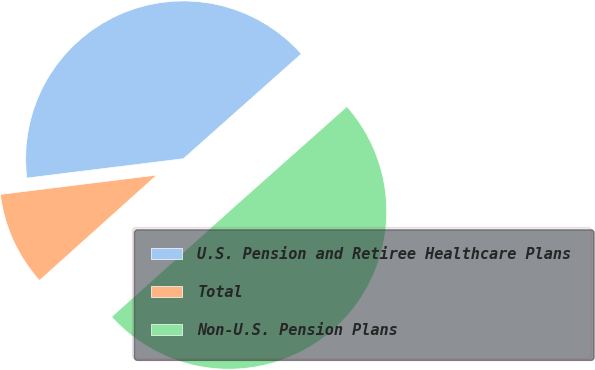Convert chart to OTSL. <chart><loc_0><loc_0><loc_500><loc_500><pie_chart><fcel>U.S. Pension and Retiree Healthcare Plans<fcel>Total<fcel>Non-U.S. Pension Plans<nl><fcel>40.39%<fcel>9.69%<fcel>49.92%<nl></chart> 